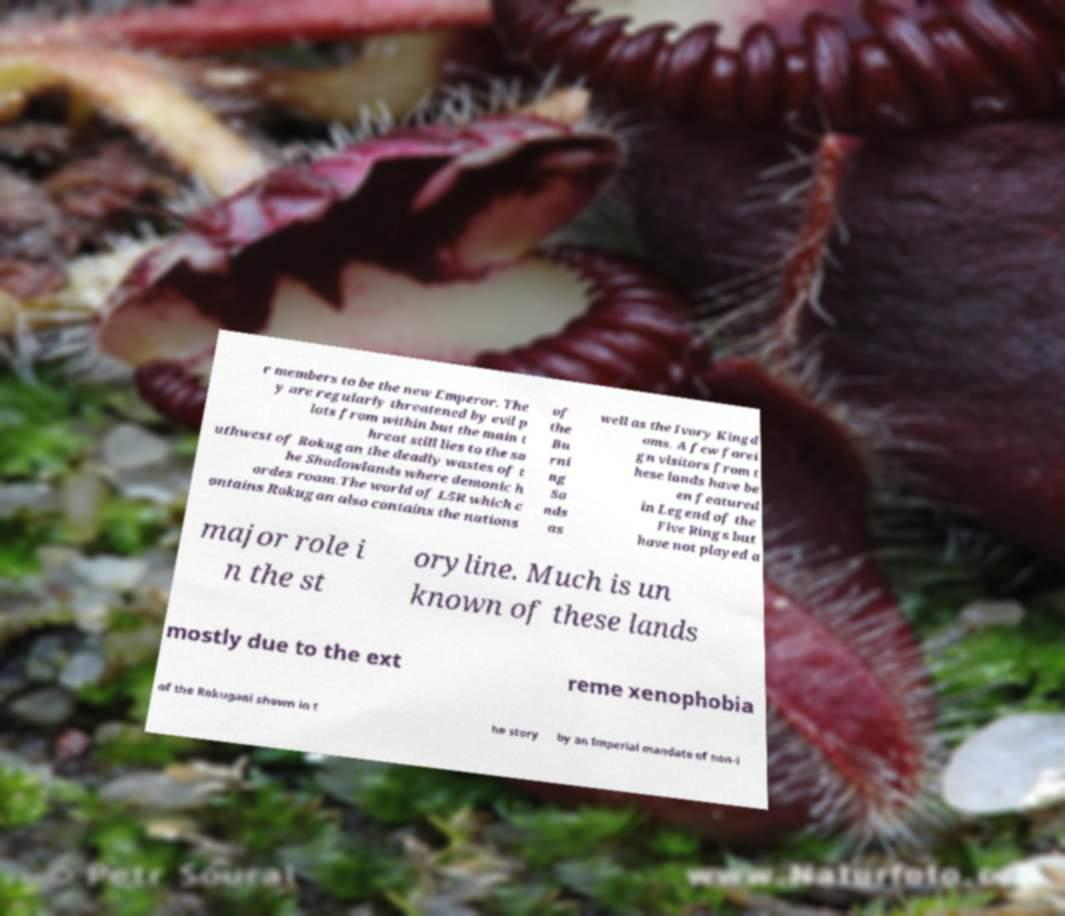There's text embedded in this image that I need extracted. Can you transcribe it verbatim? r members to be the new Emperor. The y are regularly threatened by evil p lots from within but the main t hreat still lies to the so uthwest of Rokugan the deadly wastes of t he Shadowlands where demonic h ordes roam.The world of L5R which c ontains Rokugan also contains the nations of the Bu rni ng Sa nds as well as the Ivory Kingd oms. A few forei gn visitors from t hese lands have be en featured in Legend of the Five Rings but have not played a major role i n the st oryline. Much is un known of these lands mostly due to the ext reme xenophobia of the Rokugani shown in t he story by an Imperial mandate of non-i 